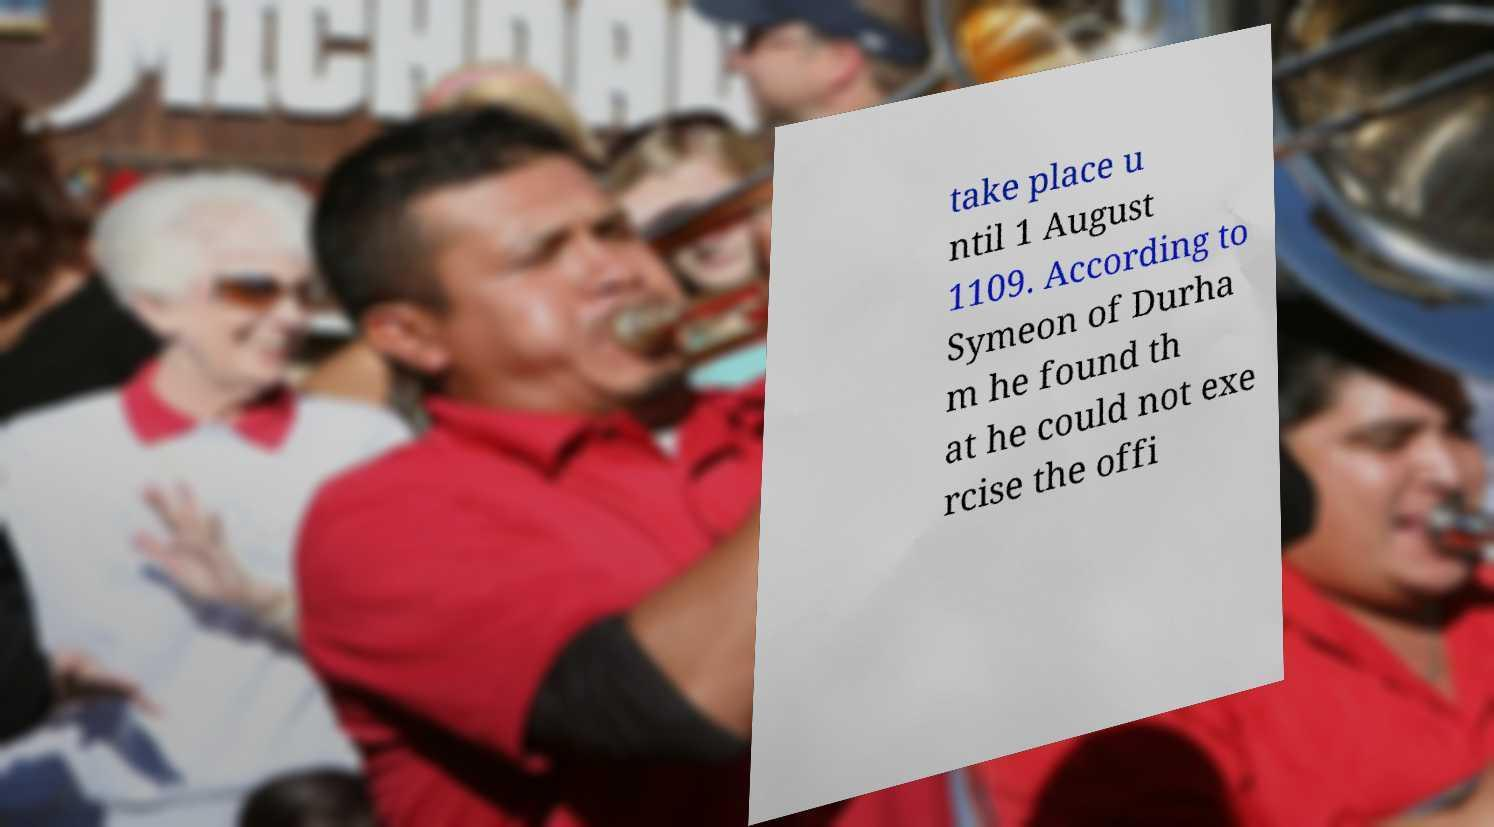I need the written content from this picture converted into text. Can you do that? take place u ntil 1 August 1109. According to Symeon of Durha m he found th at he could not exe rcise the offi 